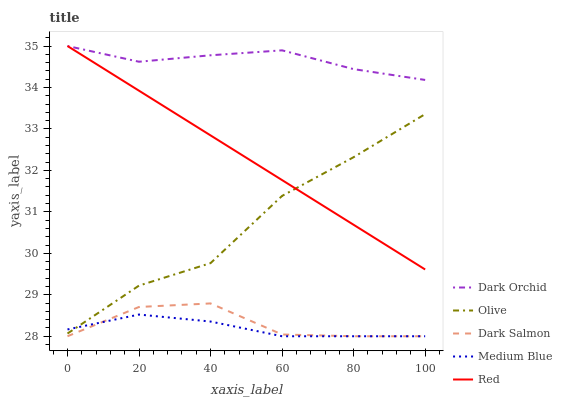Does Medium Blue have the minimum area under the curve?
Answer yes or no. Yes. Does Dark Orchid have the maximum area under the curve?
Answer yes or no. Yes. Does Red have the minimum area under the curve?
Answer yes or no. No. Does Red have the maximum area under the curve?
Answer yes or no. No. Is Red the smoothest?
Answer yes or no. Yes. Is Olive the roughest?
Answer yes or no. Yes. Is Medium Blue the smoothest?
Answer yes or no. No. Is Medium Blue the roughest?
Answer yes or no. No. Does Medium Blue have the lowest value?
Answer yes or no. Yes. Does Red have the lowest value?
Answer yes or no. No. Does Dark Orchid have the highest value?
Answer yes or no. Yes. Does Medium Blue have the highest value?
Answer yes or no. No. Is Medium Blue less than Dark Orchid?
Answer yes or no. Yes. Is Dark Orchid greater than Olive?
Answer yes or no. Yes. Does Red intersect Dark Orchid?
Answer yes or no. Yes. Is Red less than Dark Orchid?
Answer yes or no. No. Is Red greater than Dark Orchid?
Answer yes or no. No. Does Medium Blue intersect Dark Orchid?
Answer yes or no. No. 